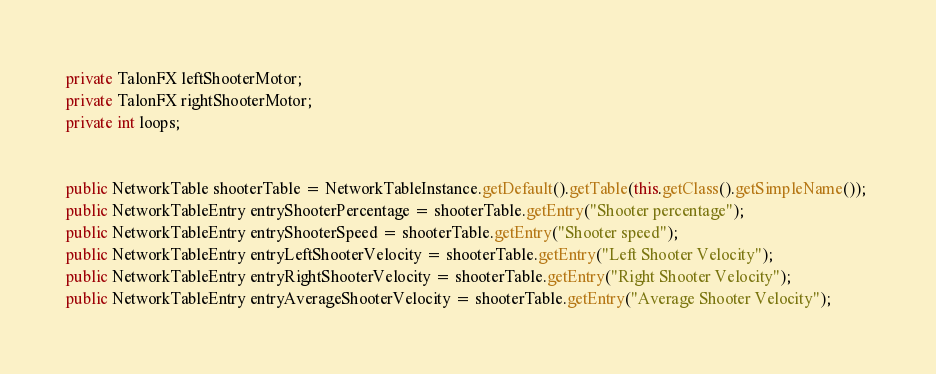<code> <loc_0><loc_0><loc_500><loc_500><_Java_>private TalonFX leftShooterMotor;
private TalonFX rightShooterMotor;
private int loops;


public NetworkTable shooterTable = NetworkTableInstance.getDefault().getTable(this.getClass().getSimpleName()); 
public NetworkTableEntry entryShooterPercentage = shooterTable.getEntry("Shooter percentage"); 
public NetworkTableEntry entryShooterSpeed = shooterTable.getEntry("Shooter speed"); 
public NetworkTableEntry entryLeftShooterVelocity = shooterTable.getEntry("Left Shooter Velocity"); 
public NetworkTableEntry entryRightShooterVelocity = shooterTable.getEntry("Right Shooter Velocity"); 
public NetworkTableEntry entryAverageShooterVelocity = shooterTable.getEntry("Average Shooter Velocity"); </code> 